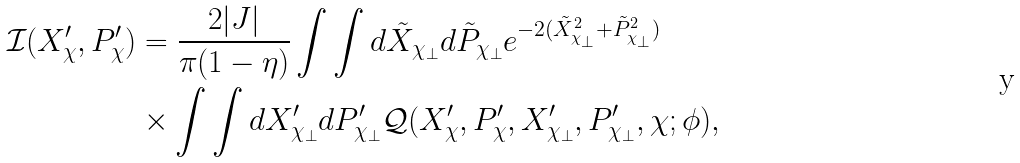Convert formula to latex. <formula><loc_0><loc_0><loc_500><loc_500>\mathcal { I } ( X ^ { \prime } _ { \chi } , P ^ { \prime } _ { \chi } ) & = \frac { 2 | J | } { \pi ( 1 - \eta ) } \int \int d \tilde { X } _ { \chi _ { \bot } } d \tilde { P } _ { \chi _ { \bot } } e ^ { - 2 ( \tilde { X } _ { \chi _ { \bot } } ^ { 2 } + \tilde { P } _ { \chi _ { \bot } } ^ { 2 } ) } \\ & \times \int \int d X ^ { \prime } _ { \chi _ { \bot } } d P ^ { \prime } _ { \chi _ { \bot } } \mathcal { Q } ( X ^ { \prime } _ { \chi } , P ^ { \prime } _ { \chi } , X ^ { \prime } _ { \chi _ { \bot } } , P ^ { \prime } _ { \chi _ { \bot } } , \chi ; \phi ) ,</formula> 